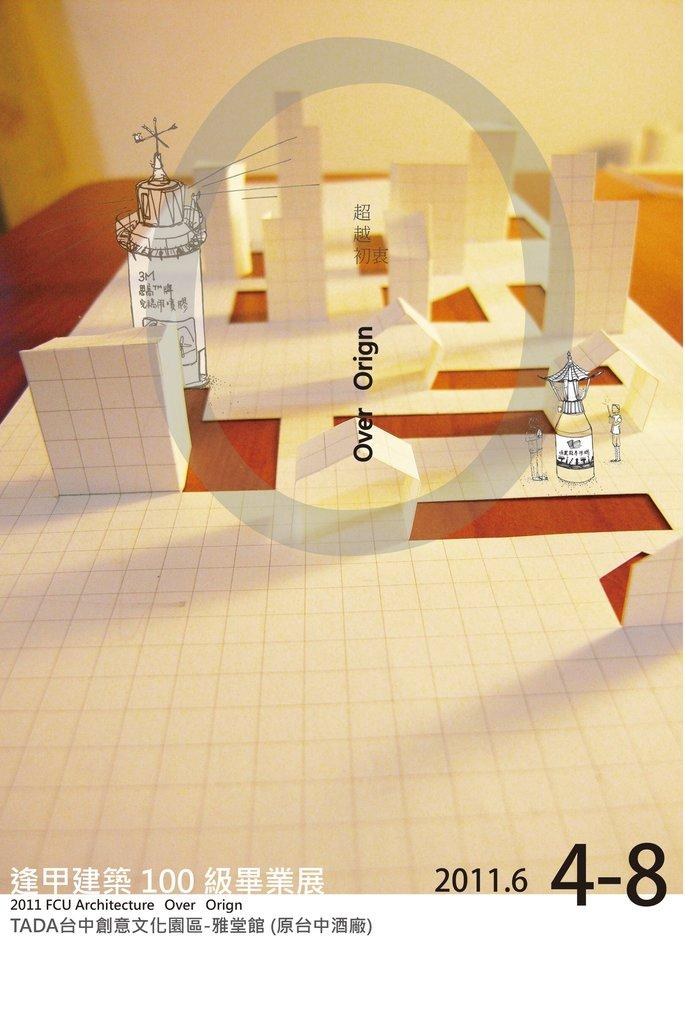What type of art is featured in the image? There is paper art in the image. Where is the paper art located? The paper art is placed on a table. What additional visual elements can be seen in the image? There are graphical effects in the image. Is there any text present in the image? Yes, there is text in the image. Can you see a tent in the image? No, there is no tent present in the image. Is there a chicken depicted in the paper art? No, there is no chicken depicted in the image; it features paper art. 